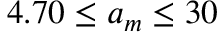<formula> <loc_0><loc_0><loc_500><loc_500>4 . 7 0 \leq a _ { m } \leq 3 0</formula> 